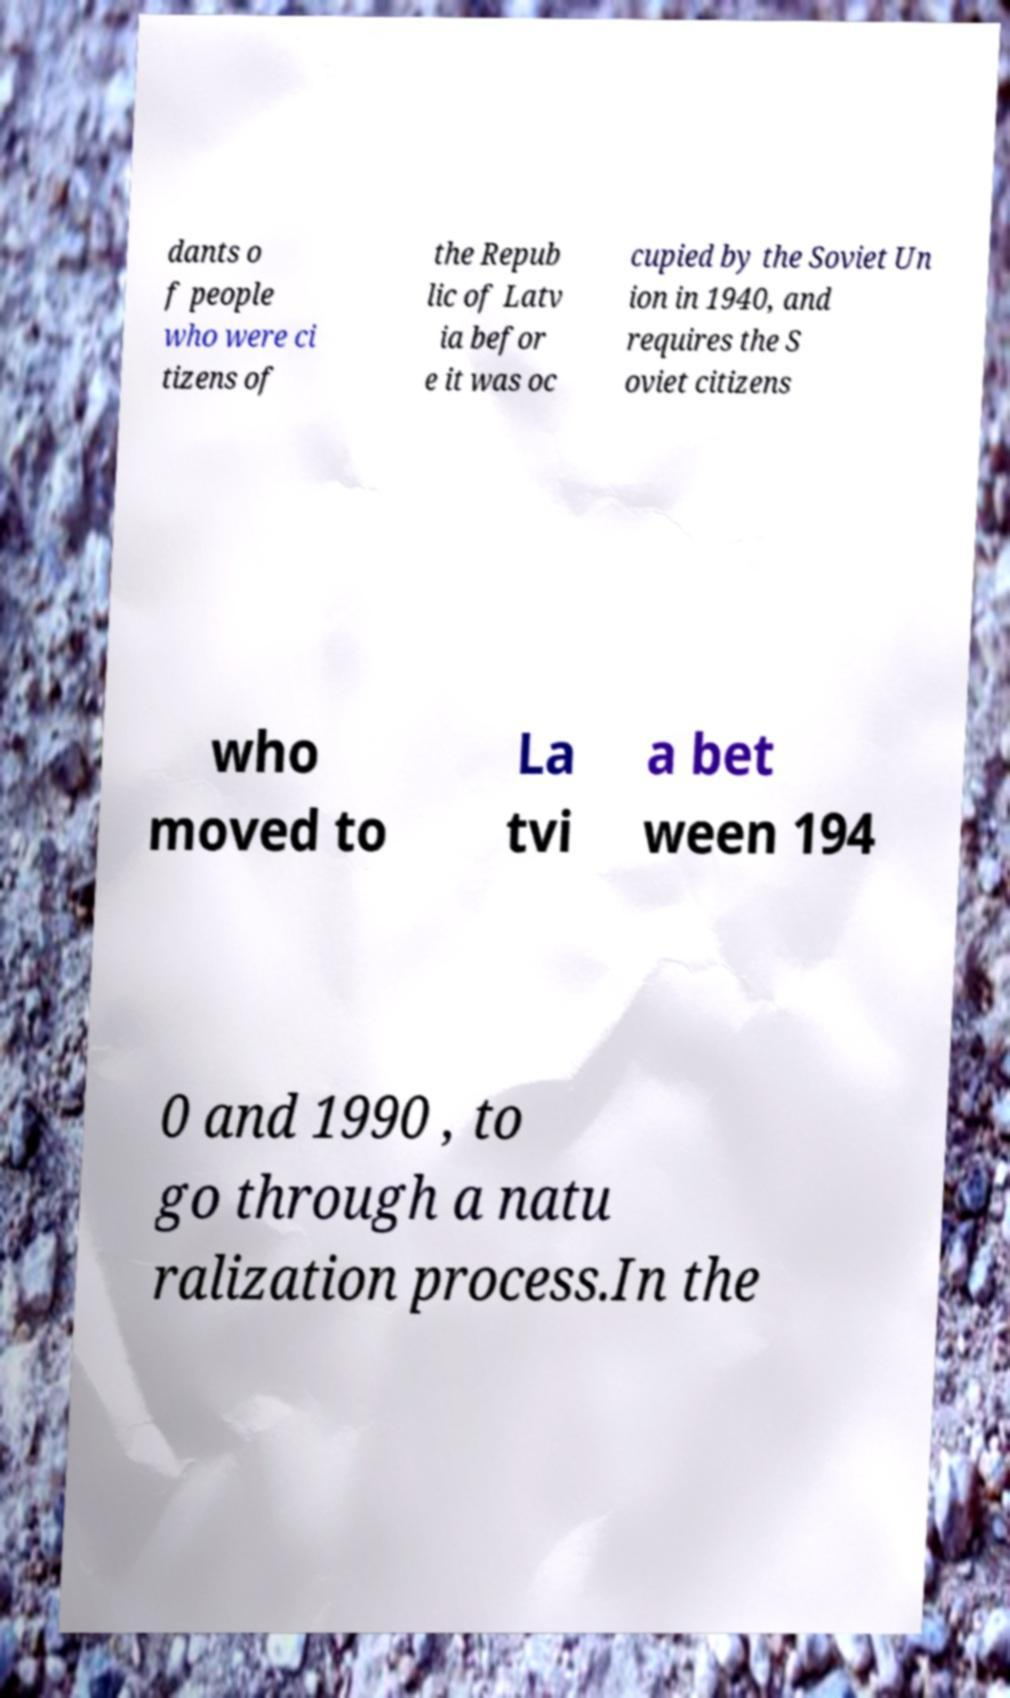Can you read and provide the text displayed in the image?This photo seems to have some interesting text. Can you extract and type it out for me? dants o f people who were ci tizens of the Repub lic of Latv ia befor e it was oc cupied by the Soviet Un ion in 1940, and requires the S oviet citizens who moved to La tvi a bet ween 194 0 and 1990 , to go through a natu ralization process.In the 